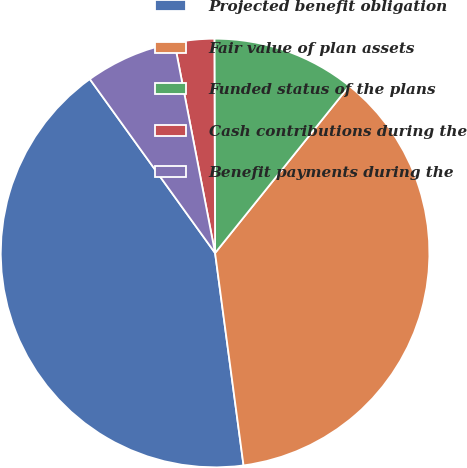<chart> <loc_0><loc_0><loc_500><loc_500><pie_chart><fcel>Projected benefit obligation<fcel>Fair value of plan assets<fcel>Funded status of the plans<fcel>Cash contributions during the<fcel>Benefit payments during the<nl><fcel>42.18%<fcel>37.11%<fcel>10.82%<fcel>2.98%<fcel>6.9%<nl></chart> 